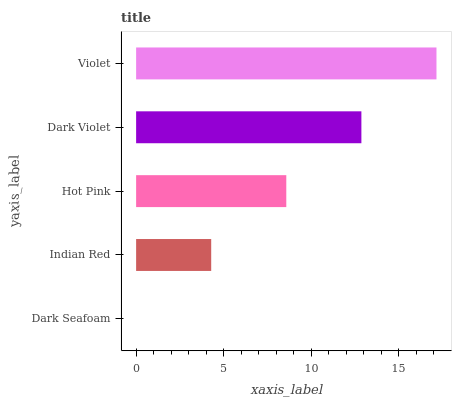Is Dark Seafoam the minimum?
Answer yes or no. Yes. Is Violet the maximum?
Answer yes or no. Yes. Is Indian Red the minimum?
Answer yes or no. No. Is Indian Red the maximum?
Answer yes or no. No. Is Indian Red greater than Dark Seafoam?
Answer yes or no. Yes. Is Dark Seafoam less than Indian Red?
Answer yes or no. Yes. Is Dark Seafoam greater than Indian Red?
Answer yes or no. No. Is Indian Red less than Dark Seafoam?
Answer yes or no. No. Is Hot Pink the high median?
Answer yes or no. Yes. Is Hot Pink the low median?
Answer yes or no. Yes. Is Dark Seafoam the high median?
Answer yes or no. No. Is Indian Red the low median?
Answer yes or no. No. 